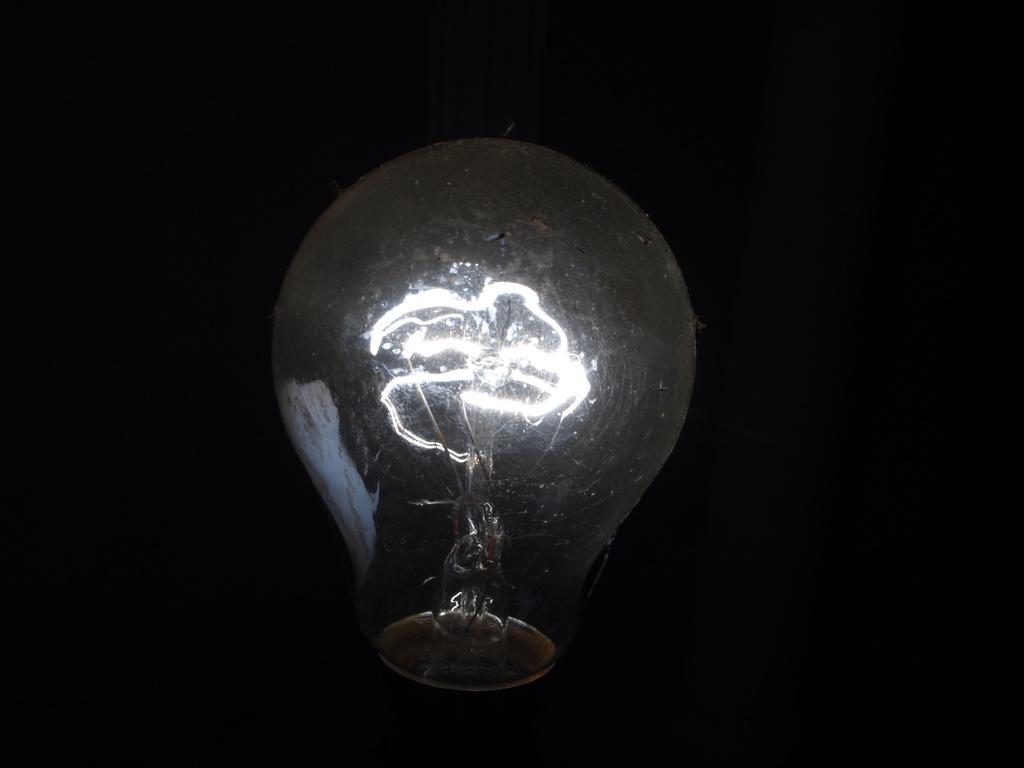In one or two sentences, can you explain what this image depicts? In this image we can see a bulb. 